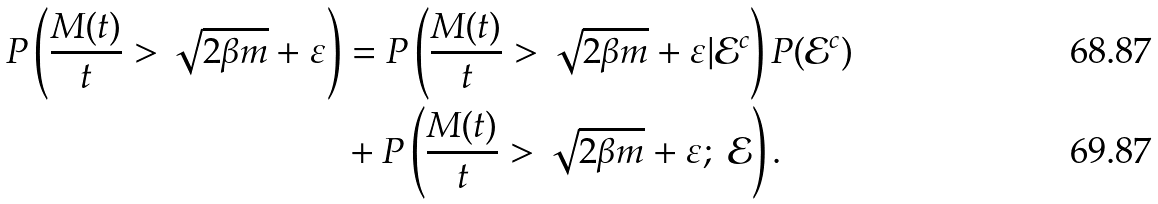Convert formula to latex. <formula><loc_0><loc_0><loc_500><loc_500>P \left ( \frac { M ( t ) } { t } > \sqrt { 2 \beta m } + \varepsilon \right ) & = P \left ( \frac { M ( t ) } { t } > \sqrt { 2 \beta m } + \varepsilon | \mathcal { E } ^ { c } \right ) P ( \mathcal { E } ^ { c } ) \\ & + P \left ( \frac { M ( t ) } { t } > \sqrt { 2 \beta m } + \varepsilon ; \ \mathcal { E } \right ) .</formula> 